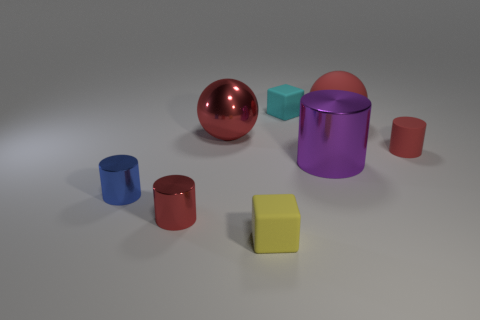Is there any other thing that is the same color as the large metal cylinder?
Offer a terse response. No. There is a tiny object that is both behind the small red shiny cylinder and in front of the purple metallic object; what color is it?
Your response must be concise. Blue. Do the metallic object that is behind the purple cylinder and the small red matte thing have the same size?
Your response must be concise. No. Is the number of large spheres to the left of the small blue metallic cylinder greater than the number of small cyan matte things?
Your answer should be compact. No. Do the cyan thing and the small blue metallic object have the same shape?
Give a very brief answer. No. How big is the cyan object?
Ensure brevity in your answer.  Small. Is the number of small blue metal cylinders that are left of the small cyan matte cube greater than the number of rubber blocks that are on the right side of the purple thing?
Your answer should be compact. Yes. There is a blue shiny thing; are there any red matte objects on the left side of it?
Ensure brevity in your answer.  No. Are there any purple objects that have the same size as the red rubber cylinder?
Your answer should be very brief. No. There is a ball that is the same material as the large cylinder; what color is it?
Give a very brief answer. Red. 